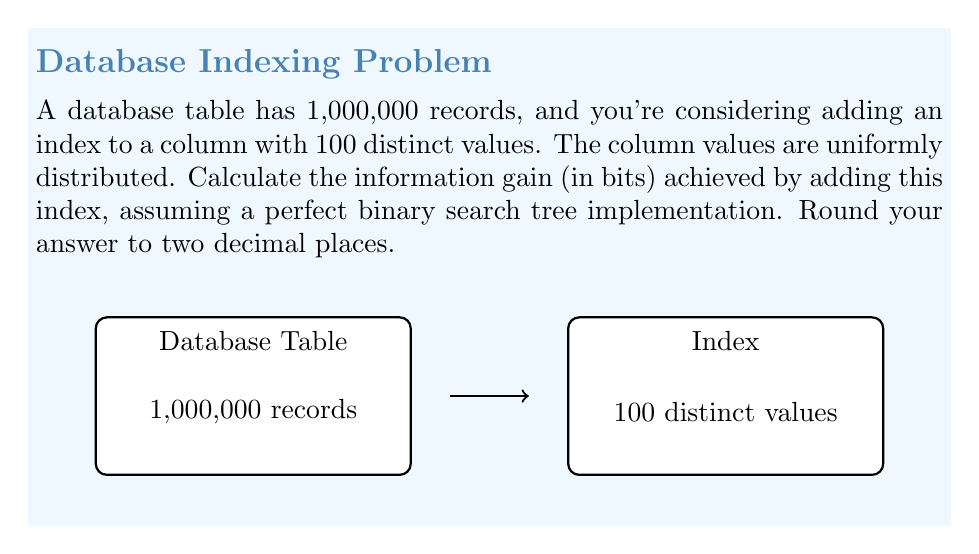Show me your answer to this math problem. Let's approach this step-by-step:

1) Without an index, we would need to search through all 1,000,000 records to find a specific value. The information content of this situation is:

   $$H_1 = \log_2(1,000,000) \approx 19.93$$

2) With an index on a column with 100 distinct values, we can use binary search to find the desired value. The number of comparisons needed for binary search in a balanced tree of 100 elements is:

   $$\log_2(100) \approx 6.64$$

3) After finding the correct group in the index, we still need to locate the specific record within that group. On average, there will be 1,000,000 / 100 = 10,000 records per distinct value.

4) The information content of searching within this group is:

   $$H_2 = \log_2(10,000) \approx 13.29$$

5) The total information content with the index is the sum of steps 2 and 4:

   $$H_{total} = 6.64 + 13.29 \approx 19.93$$

6) The information gain is the difference between the information content without the index and with the index:

   $$\text{Information Gain} = H_1 - H_{total} = 19.93 - 19.93 = 0$$

7) Rounding to two decimal places, the result is 0.00 bits.

This result shows that in this specific case, the index doesn't provide any information gain. This is because the uniform distribution of values means that even after using the index, we still need to search through a large number of records on average.
Answer: 0.00 bits 